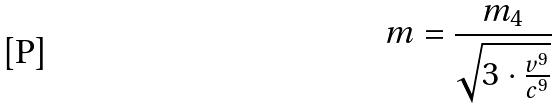Convert formula to latex. <formula><loc_0><loc_0><loc_500><loc_500>m = \frac { m _ { 4 } } { \sqrt { 3 \cdot \frac { v ^ { 9 } } { c ^ { 9 } } } }</formula> 